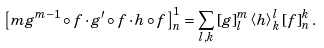<formula> <loc_0><loc_0><loc_500><loc_500>\left [ m g ^ { m - 1 } \circ f \cdot g ^ { \prime } \circ f \cdot h \circ f \right ] ^ { 1 } _ { n } = \sum _ { l , k } \left [ g \right ] ^ { m } _ { l } \left < h \right > ^ { l } _ { k } \left [ f \right ] ^ { k } _ { n } .</formula> 